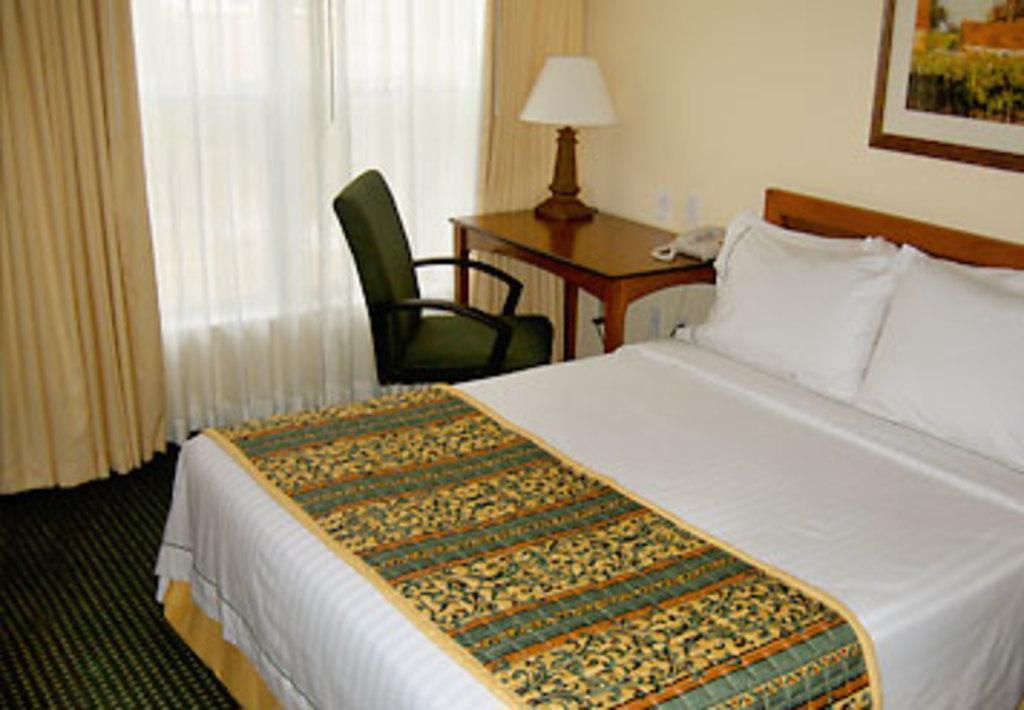Can you describe this image briefly? This image is clicked inside a room. There is the bed in the middle. There are pillows on bed. There is a table and chair. On the table there is light. There are curtains in the middle. There is a photo frame in the top right corner. 